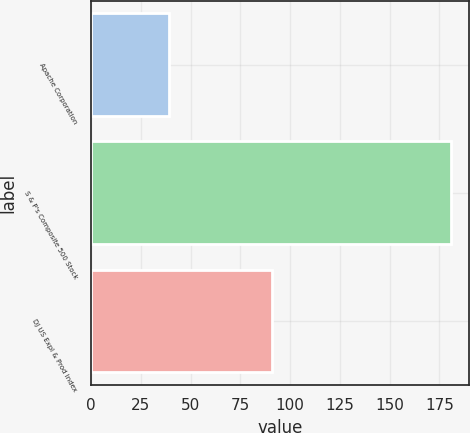Convert chart. <chart><loc_0><loc_0><loc_500><loc_500><bar_chart><fcel>Apache Corporation<fcel>S & P's Composite 500 Stock<fcel>DJ US Expl & Prod Index<nl><fcel>39.27<fcel>180.75<fcel>90.97<nl></chart> 